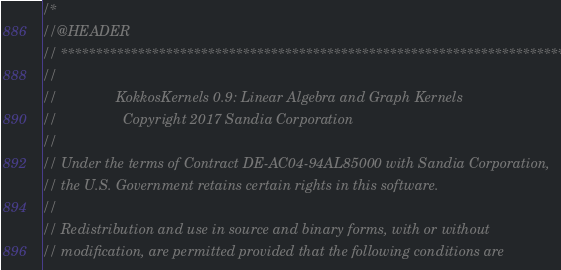Convert code to text. <code><loc_0><loc_0><loc_500><loc_500><_C++_>/*
//@HEADER
// ************************************************************************
//
//               KokkosKernels 0.9: Linear Algebra and Graph Kernels
//                 Copyright 2017 Sandia Corporation
//
// Under the terms of Contract DE-AC04-94AL85000 with Sandia Corporation,
// the U.S. Government retains certain rights in this software.
//
// Redistribution and use in source and binary forms, with or without
// modification, are permitted provided that the following conditions are</code> 